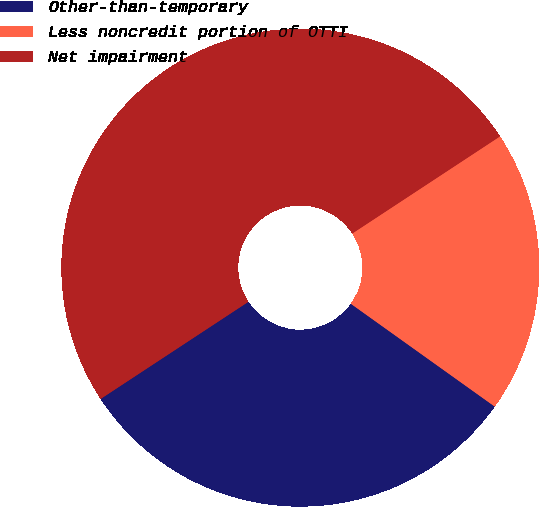<chart> <loc_0><loc_0><loc_500><loc_500><pie_chart><fcel>Other-than-temporary<fcel>Less noncredit portion of OTTI<fcel>Net impairment<nl><fcel>30.87%<fcel>19.13%<fcel>50.0%<nl></chart> 